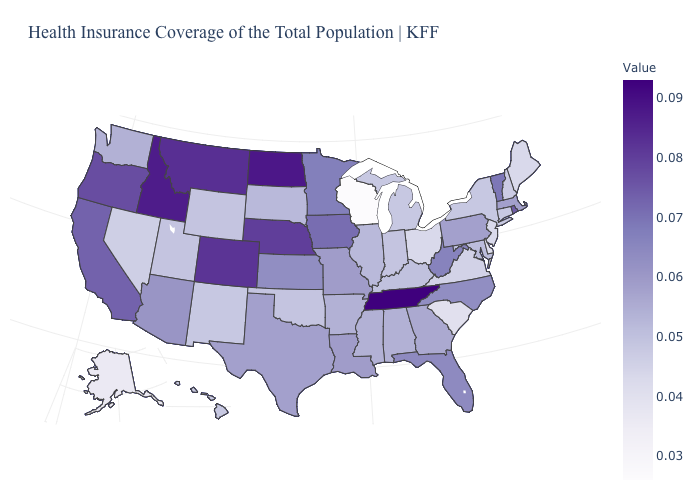Does West Virginia have the highest value in the USA?
Short answer required. No. Does the map have missing data?
Write a very short answer. No. Which states have the highest value in the USA?
Concise answer only. Tennessee. Does Wisconsin have the lowest value in the USA?
Write a very short answer. Yes. Which states have the lowest value in the USA?
Be succinct. Wisconsin. 